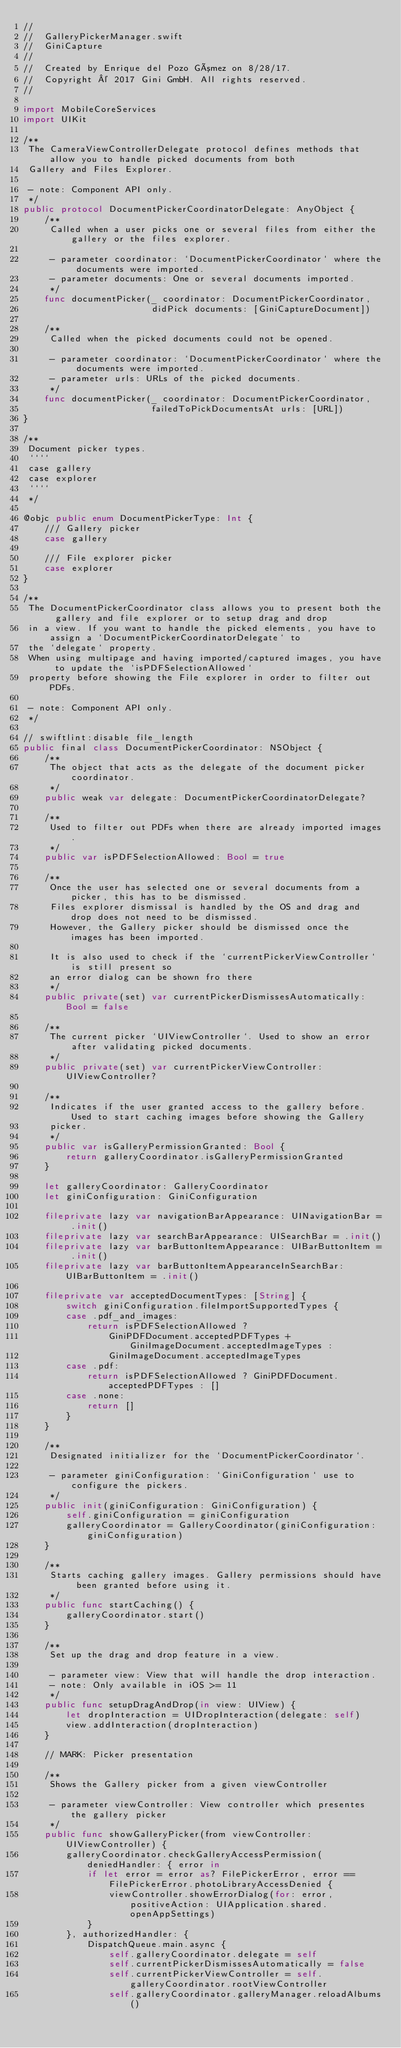Convert code to text. <code><loc_0><loc_0><loc_500><loc_500><_Swift_>//
//  GalleryPickerManager.swift
//  GiniCapture
//
//  Created by Enrique del Pozo Gómez on 8/28/17.
//  Copyright © 2017 Gini GmbH. All rights reserved.
//

import MobileCoreServices
import UIKit

/**
 The CameraViewControllerDelegate protocol defines methods that allow you to handle picked documents from both
 Gallery and Files Explorer.

 - note: Component API only.
 */
public protocol DocumentPickerCoordinatorDelegate: AnyObject {
    /**
     Called when a user picks one or several files from either the gallery or the files explorer.

     - parameter coordinator: `DocumentPickerCoordinator` where the documents were imported.
     - parameter documents: One or several documents imported.
     */
    func documentPicker(_ coordinator: DocumentPickerCoordinator,
                        didPick documents: [GiniCaptureDocument])

    /**
     Called when the picked documents could not be opened.

     - parameter coordinator: `DocumentPickerCoordinator` where the documents were imported.
     - parameter urls: URLs of the picked documents.
     */
    func documentPicker(_ coordinator: DocumentPickerCoordinator,
                        failedToPickDocumentsAt urls: [URL])
}

/**
 Document picker types.
 ````
 case gallery
 case explorer
 ````
 */

@objc public enum DocumentPickerType: Int {
    /// Gallery picker
    case gallery

    /// File explorer picker
    case explorer
}

/**
 The DocumentPickerCoordinator class allows you to present both the gallery and file explorer or to setup drag and drop
 in a view. If you want to handle the picked elements, you have to assign a `DocumentPickerCoordinatorDelegate` to
 the `delegate` property.
 When using multipage and having imported/captured images, you have to update the `isPDFSelectionAllowed`
 property before showing the File explorer in order to filter out PDFs.

 - note: Component API only.
 */

// swiftlint:disable file_length
public final class DocumentPickerCoordinator: NSObject {
    /**
     The object that acts as the delegate of the document picker coordinator.
     */
    public weak var delegate: DocumentPickerCoordinatorDelegate?

    /**
     Used to filter out PDFs when there are already imported images.
     */
    public var isPDFSelectionAllowed: Bool = true

    /**
     Once the user has selected one or several documents from a picker, this has to be dismissed.
     Files explorer dismissal is handled by the OS and drag and drop does not need to be dismissed.
     However, the Gallery picker should be dismissed once the images has been imported.

     It is also used to check if the `currentPickerViewController` is still present so
     an error dialog can be shown fro there
     */
    public private(set) var currentPickerDismissesAutomatically: Bool = false

    /**
     The current picker `UIViewController`. Used to show an error after validating picked documents.
     */
    public private(set) var currentPickerViewController: UIViewController?

    /**
     Indicates if the user granted access to the gallery before. Used to start caching images before showing the Gallery
     picker.
     */
    public var isGalleryPermissionGranted: Bool {
        return galleryCoordinator.isGalleryPermissionGranted
    }

    let galleryCoordinator: GalleryCoordinator
    let giniConfiguration: GiniConfiguration

    fileprivate lazy var navigationBarAppearance: UINavigationBar = .init()
    fileprivate lazy var searchBarAppearance: UISearchBar = .init()
    fileprivate lazy var barButtonItemAppearance: UIBarButtonItem = .init()
    fileprivate lazy var barButtonItemAppearanceInSearchBar: UIBarButtonItem = .init()

    fileprivate var acceptedDocumentTypes: [String] {
        switch giniConfiguration.fileImportSupportedTypes {
        case .pdf_and_images:
            return isPDFSelectionAllowed ?
                GiniPDFDocument.acceptedPDFTypes + GiniImageDocument.acceptedImageTypes :
                GiniImageDocument.acceptedImageTypes
        case .pdf:
            return isPDFSelectionAllowed ? GiniPDFDocument.acceptedPDFTypes : []
        case .none:
            return []
        }
    }

    /**
     Designated initializer for the `DocumentPickerCoordinator`.

     - parameter giniConfiguration: `GiniConfiguration` use to configure the pickers.
     */
    public init(giniConfiguration: GiniConfiguration) {
        self.giniConfiguration = giniConfiguration
        galleryCoordinator = GalleryCoordinator(giniConfiguration: giniConfiguration)
    }

    /**
     Starts caching gallery images. Gallery permissions should have been granted before using it.
     */
    public func startCaching() {
        galleryCoordinator.start()
    }

    /**
     Set up the drag and drop feature in a view.

     - parameter view: View that will handle the drop interaction.
     - note: Only available in iOS >= 11
     */
    public func setupDragAndDrop(in view: UIView) {
        let dropInteraction = UIDropInteraction(delegate: self)
        view.addInteraction(dropInteraction)
    }

    // MARK: Picker presentation

    /**
     Shows the Gallery picker from a given viewController

     - parameter viewController: View controller which presentes the gallery picker
     */
    public func showGalleryPicker(from viewController: UIViewController) {
        galleryCoordinator.checkGalleryAccessPermission(deniedHandler: { error in
            if let error = error as? FilePickerError, error == FilePickerError.photoLibraryAccessDenied {
                viewController.showErrorDialog(for: error, positiveAction: UIApplication.shared.openAppSettings)
            }
        }, authorizedHandler: {
            DispatchQueue.main.async {
                self.galleryCoordinator.delegate = self
                self.currentPickerDismissesAutomatically = false
                self.currentPickerViewController = self.galleryCoordinator.rootViewController
                self.galleryCoordinator.galleryManager.reloadAlbums()
</code> 